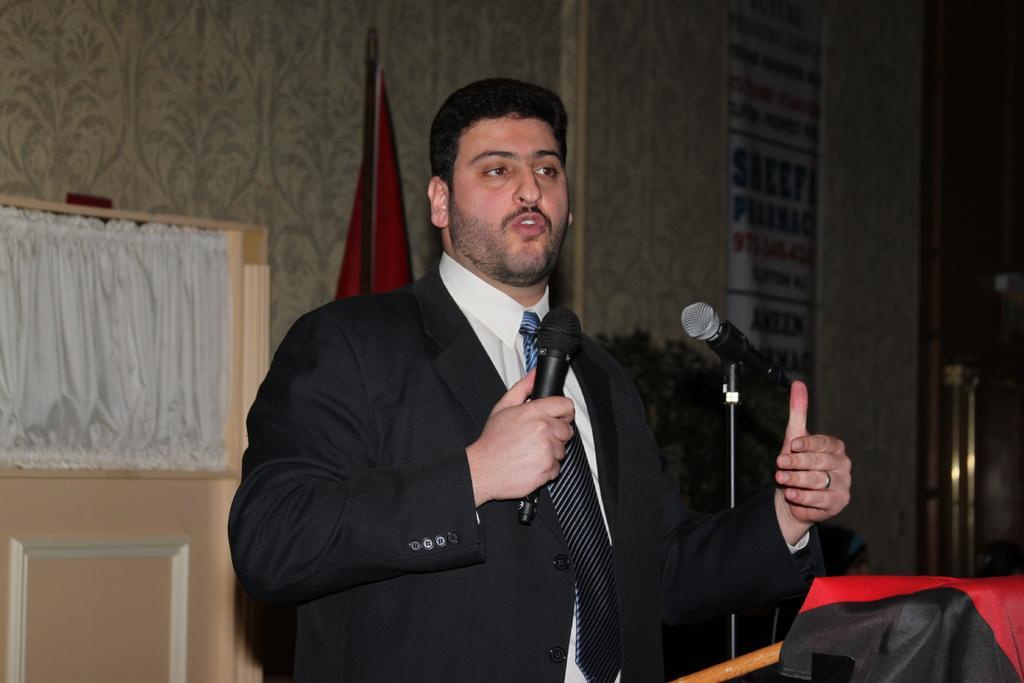In one or two sentences, can you explain what this image depicts? This man wore black suit, tie and talking in-front of mic. A banner is on wall. Beside this man there is a mic with stand. This is flag. 